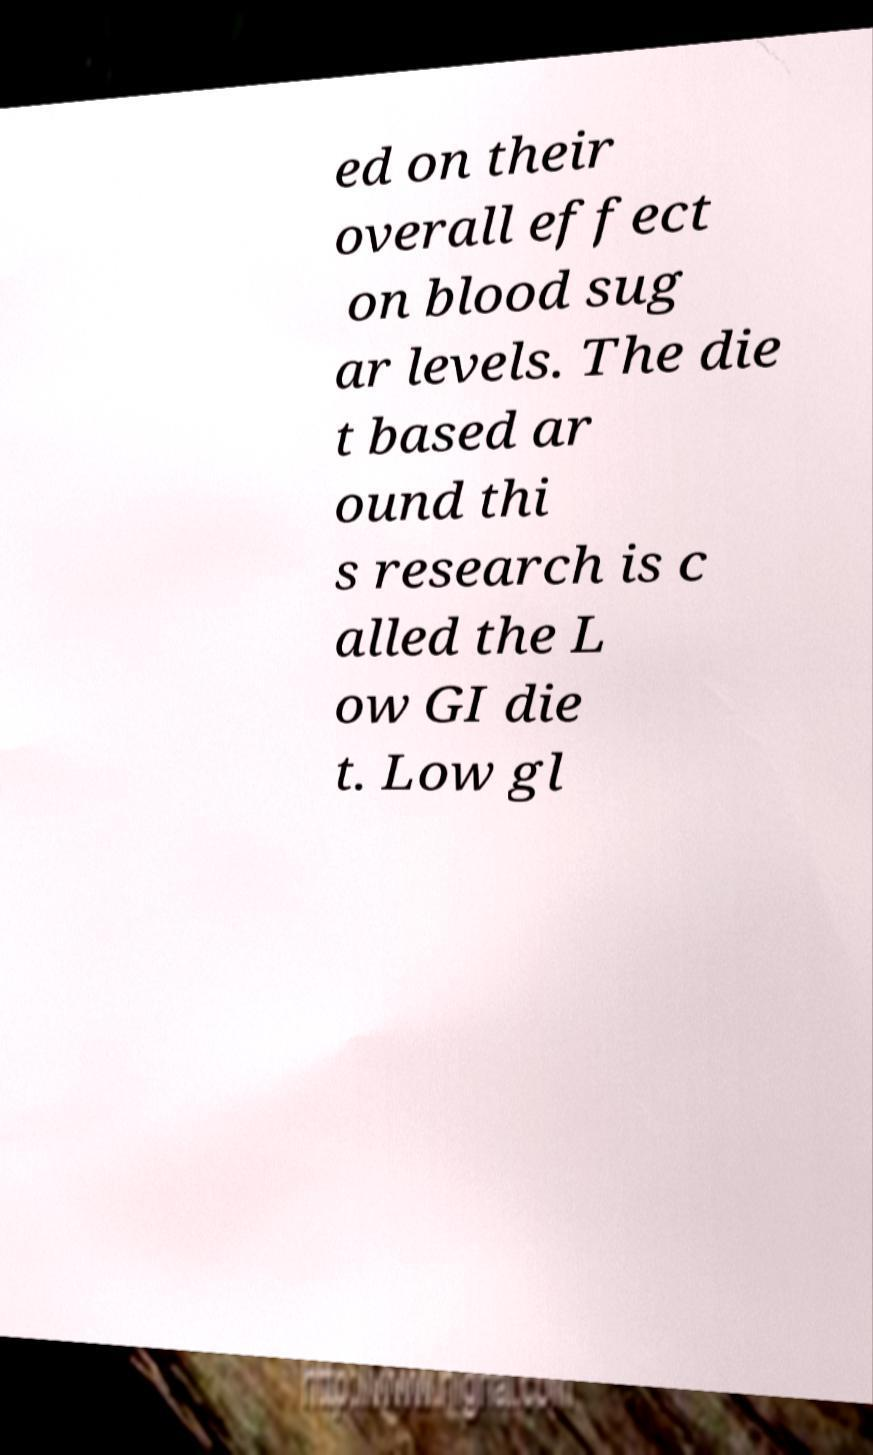Please identify and transcribe the text found in this image. ed on their overall effect on blood sug ar levels. The die t based ar ound thi s research is c alled the L ow GI die t. Low gl 